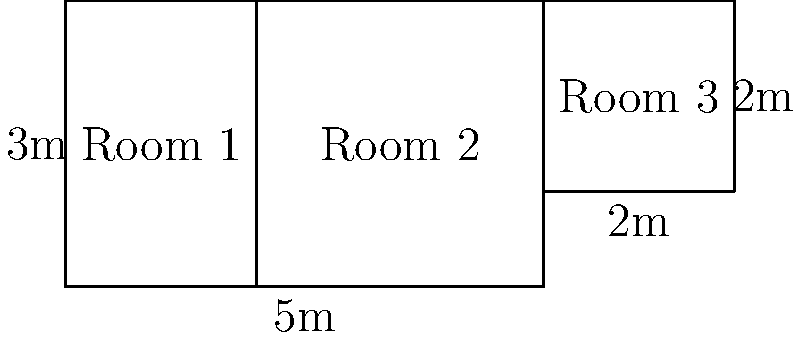As a counselor working with crime victims, you're assisting in the redesign of a police station's interview rooms to create a more comfortable environment. The station has three differently sized rooms as shown in the diagram. Room 1 and Room 2 form a rectangle, while Room 3 is separate. What is the total area of all three interview rooms in square meters? Let's calculate the area of each room step by step:

1. Room 1 and Room 2 (combined):
   - Width = $5$ m
   - Height = $3$ m
   - Area = $5 \times 3 = 15$ sq m

2. Room 3:
   - Width = $2$ m
   - Height = $2$ m
   - Area = $2 \times 2 = 4$ sq m

3. Total area:
   - Sum of all room areas = Area of (Room 1 + Room 2) + Area of Room 3
   - Total Area = $15 + 4 = 19$ sq m

Therefore, the total area of all three interview rooms is 19 square meters.
Answer: 19 sq m 